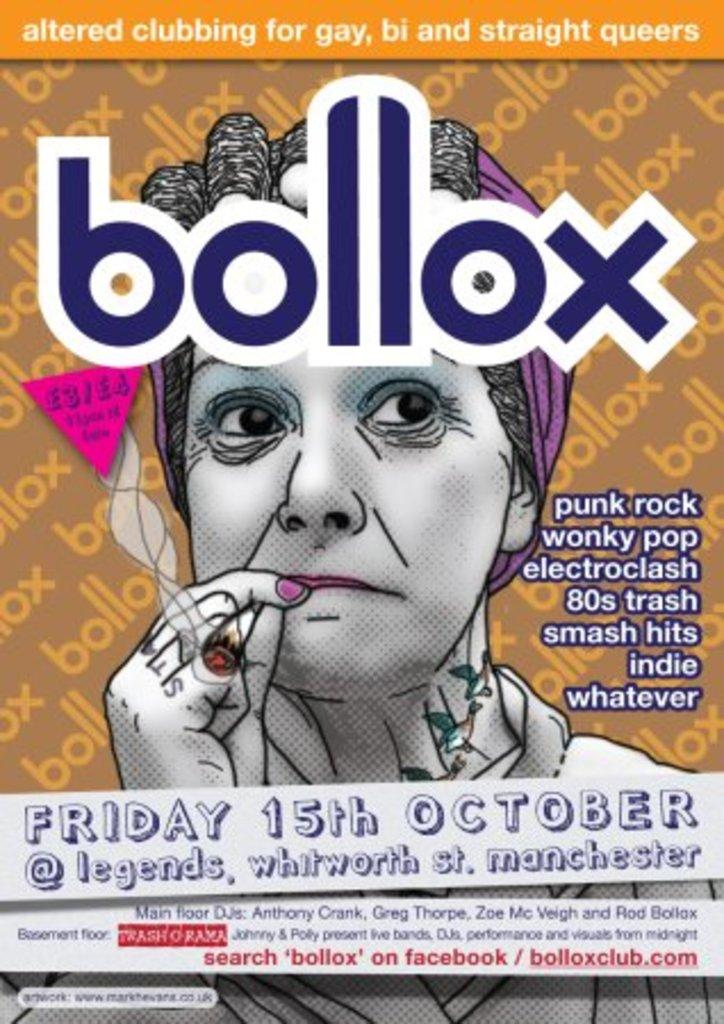What is depicted on the poster in the image? The poster features a woman smoking. What additional information is on the poster? The name "blocks" is on the poster, along with the date "Friday 15th October" and the location "legends, Manchester." What type of railway is visible on the side of the poster? There is no railway present on the poster; it features a woman smoking and additional information about an event. 